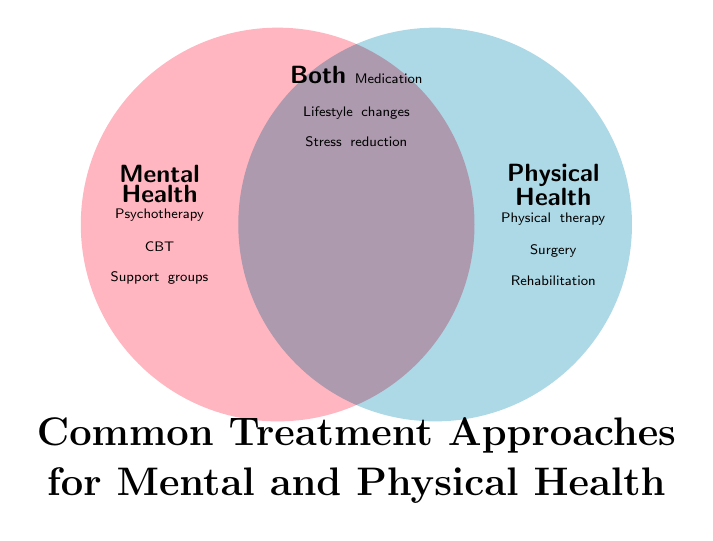Which treatments are used for both mental and physical health? The figure has a section labeled "Both" which includes treatments applicable to both mental and physical health.
Answer: Medication, Lifestyle changes, Stress reduction What are the treatment approaches listed under mental health? The "Mental Health" section of the figure lists treatments specific to mental health.
Answer: Psychotherapy, CBT, Support groups Is physical therapy a treatment for mental, physical, or both types of health? Physical therapy is listed under the "Physical Health" section, indicating it is a treatment for physical health.
Answer: Physical health How many treatment approaches are listed under physical health? The section labeled "Physical Health" includes three treatment approaches.
Answer: Three Which treatment approach appears in all three categories? No single treatment approach appears in all three categories based on the provided sections.
Answer: None Compare the number of treatments listed for mental and physical health. Which category has more? By counting, both the "Mental Health" and "Physical Health" sections have three treatments listed each.
Answer: Equal What are the stress reduction techniques classified under? The figure lists stress reduction techniques under the "Both" section, indicating it is applicable to both mental and physical health.
Answer: Both Are support groups considered a treatment more for mental health or physical health? Support groups are listed under the "Mental Health" section, indicating they are more a treatment for mental health.
Answer: Mental health What treatment is common between mental health and physical health but not listed in the individual sections for mental or physical health? The treatments listed in the "Both" section but not in individual sections are common to both types of health.
Answer: Medication, Lifestyle changes, Stress reduction 